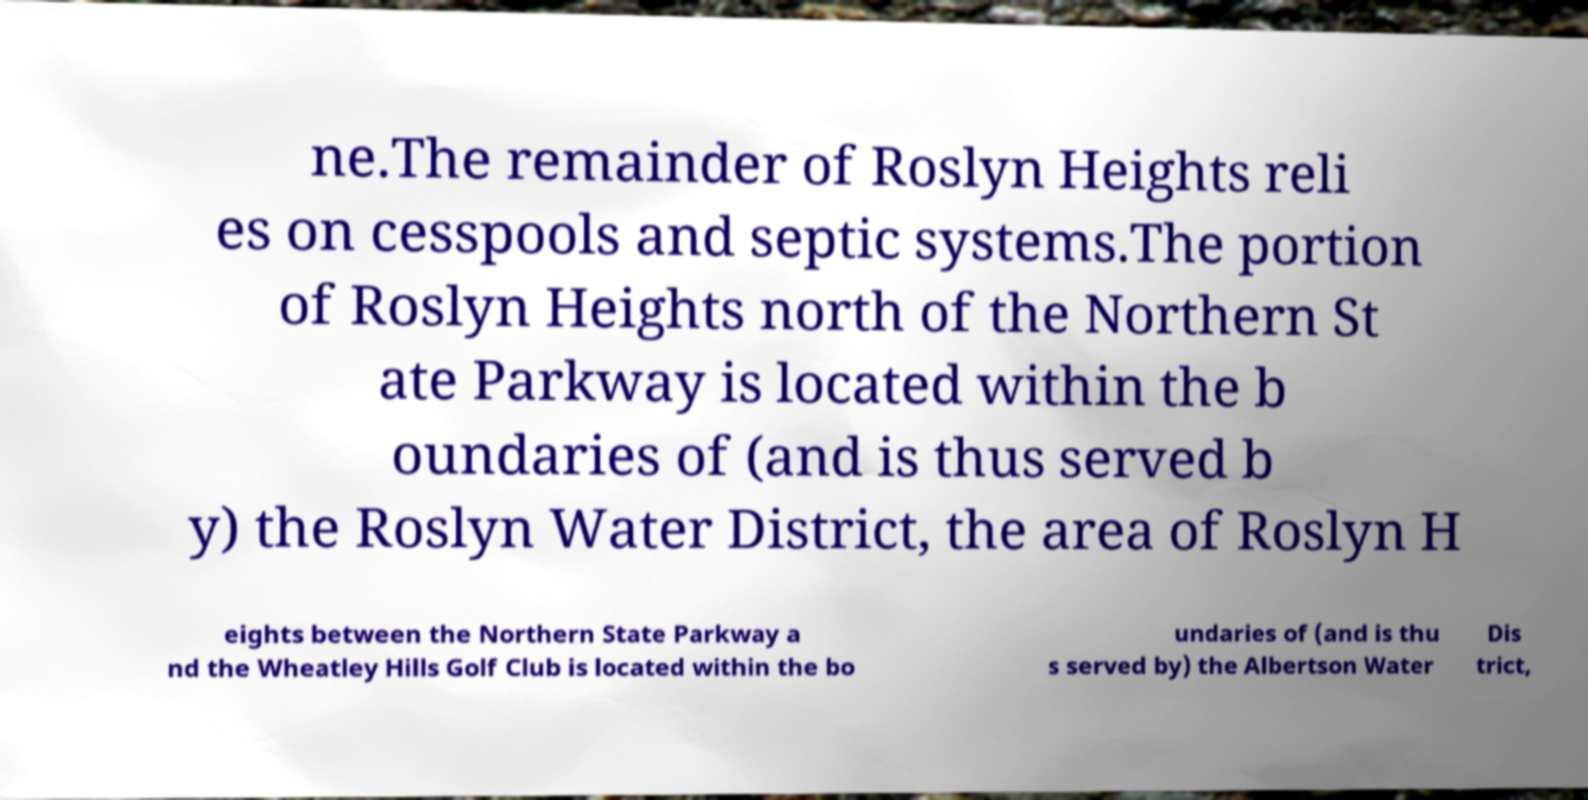Can you read and provide the text displayed in the image?This photo seems to have some interesting text. Can you extract and type it out for me? ne.The remainder of Roslyn Heights reli es on cesspools and septic systems.The portion of Roslyn Heights north of the Northern St ate Parkway is located within the b oundaries of (and is thus served b y) the Roslyn Water District, the area of Roslyn H eights between the Northern State Parkway a nd the Wheatley Hills Golf Club is located within the bo undaries of (and is thu s served by) the Albertson Water Dis trict, 